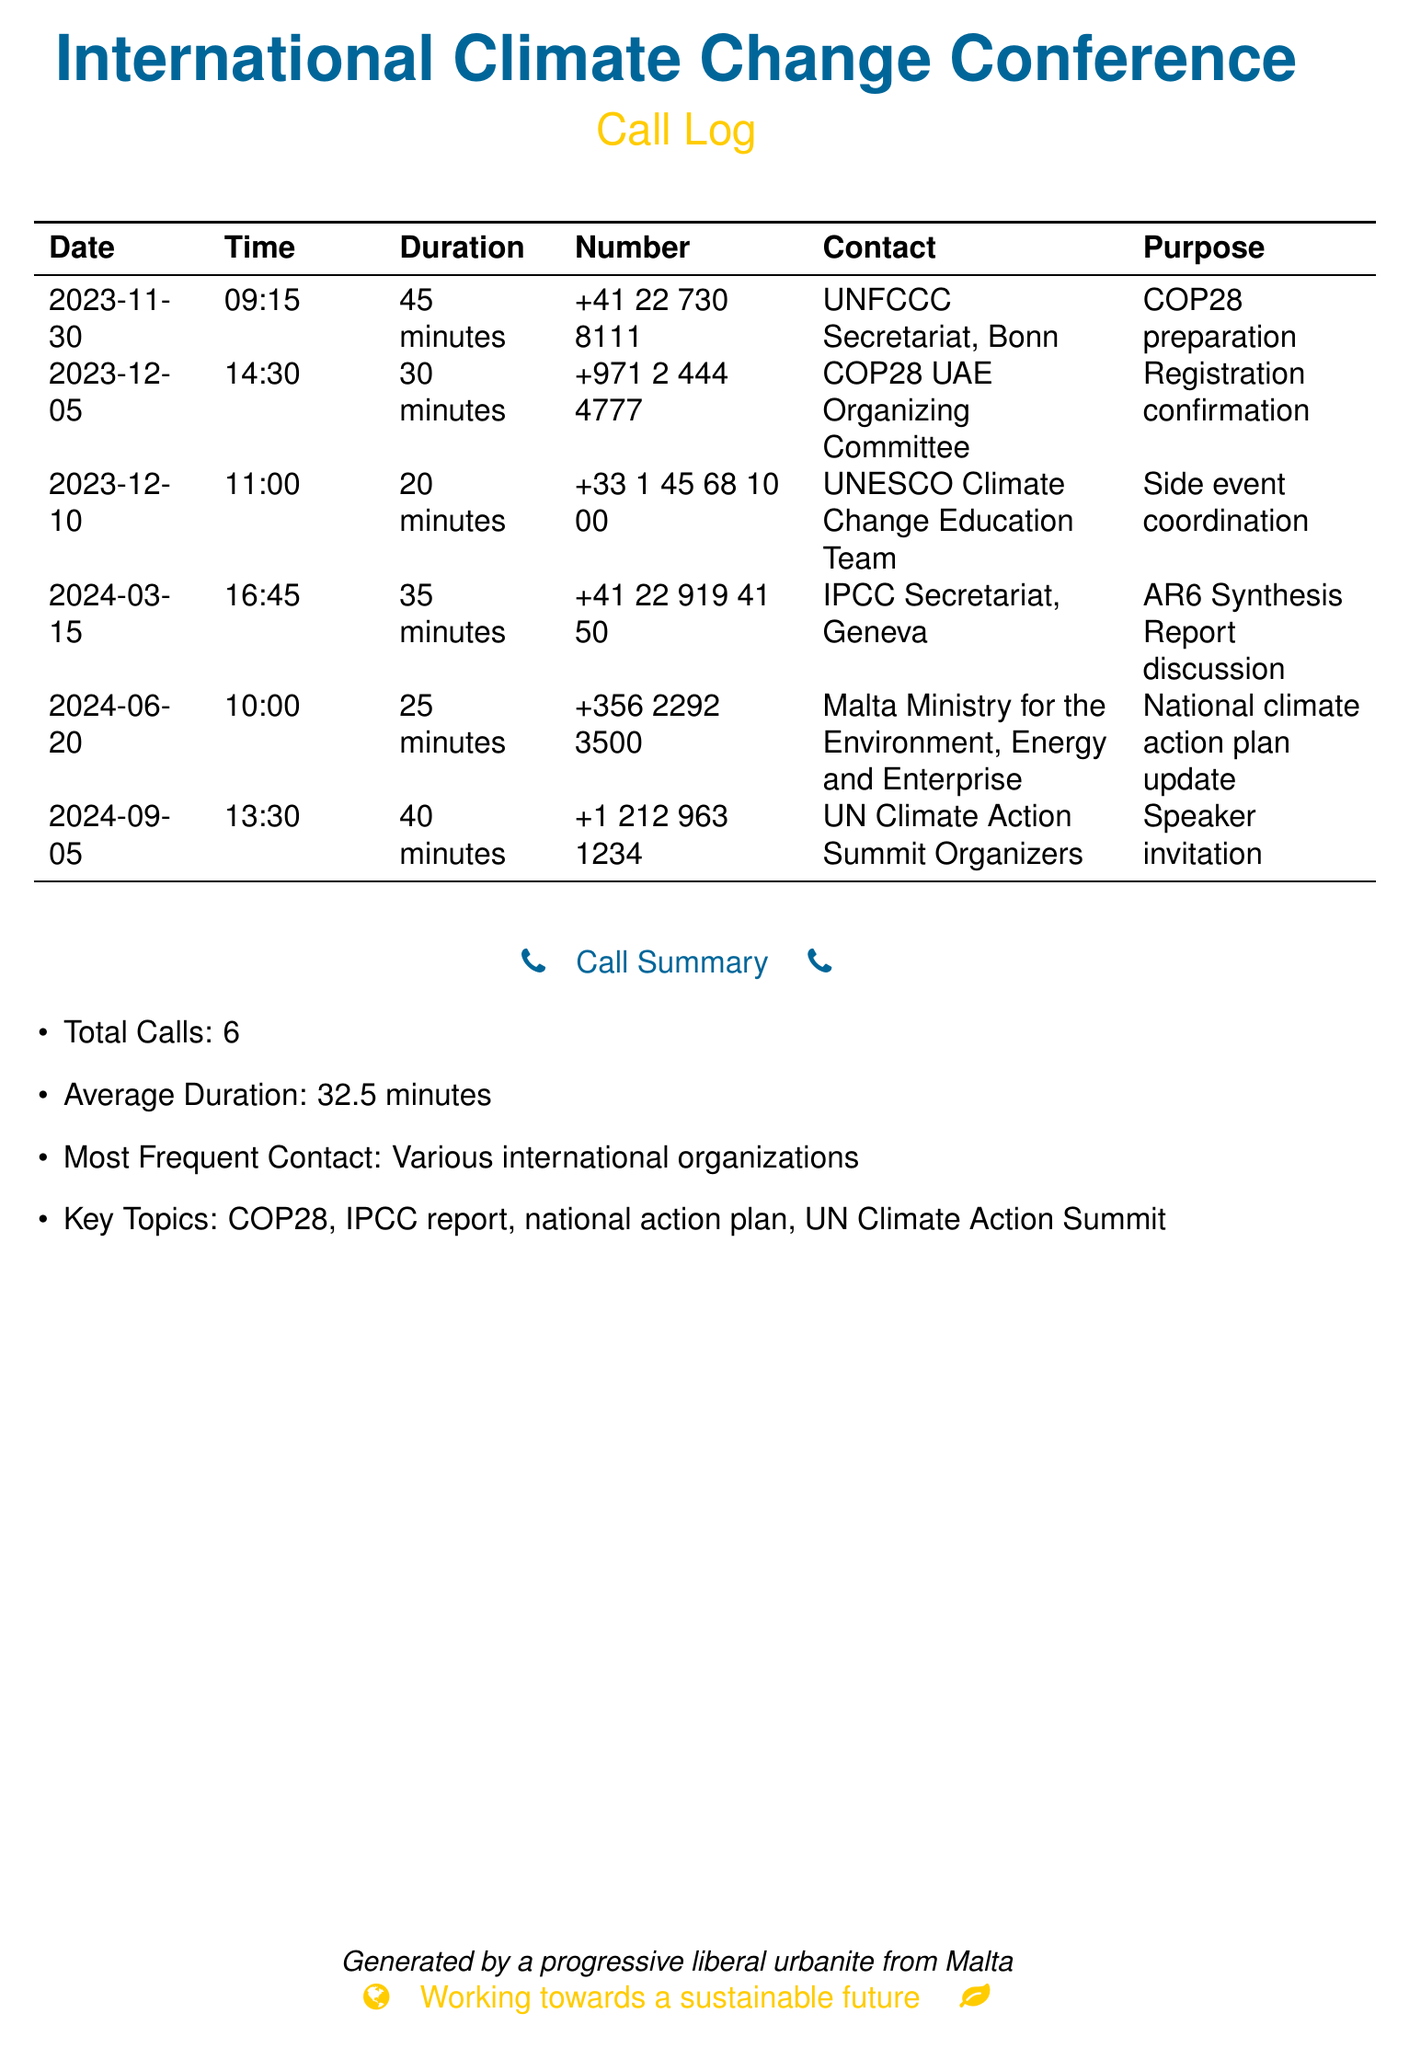What was the duration of the call to the UNFCCC Secretariat? The call to the UNFCCC Secretariat lasted for 45 minutes.
Answer: 45 minutes Who was the contact for the call on December 5, 2023? The contact for this call was the COP28 UAE Organizing Committee.
Answer: COP28 UAE Organizing Committee How many total calls are listed in the call summary? The call summary states that there were 6 total calls made.
Answer: 6 What was the purpose of the call on June 20, 2024? The purpose of this call was to update on the national climate action plan.
Answer: National climate action plan update Which organization was most frequently contacted? The document indicates that various international organizations were contacted most frequently.
Answer: Various international organizations What was the average duration of the calls listed? The average duration is calculated as 32.5 minutes from the total durations provided.
Answer: 32.5 minutes On what date was the call regarding the AR6 Synthesis Report discussion made? The call regarding this discussion was made on March 15, 2024.
Answer: 2024-03-15 What is one key topic mentioned in the call summary? The key topic mentioned in the call summary is COP28.
Answer: COP28 